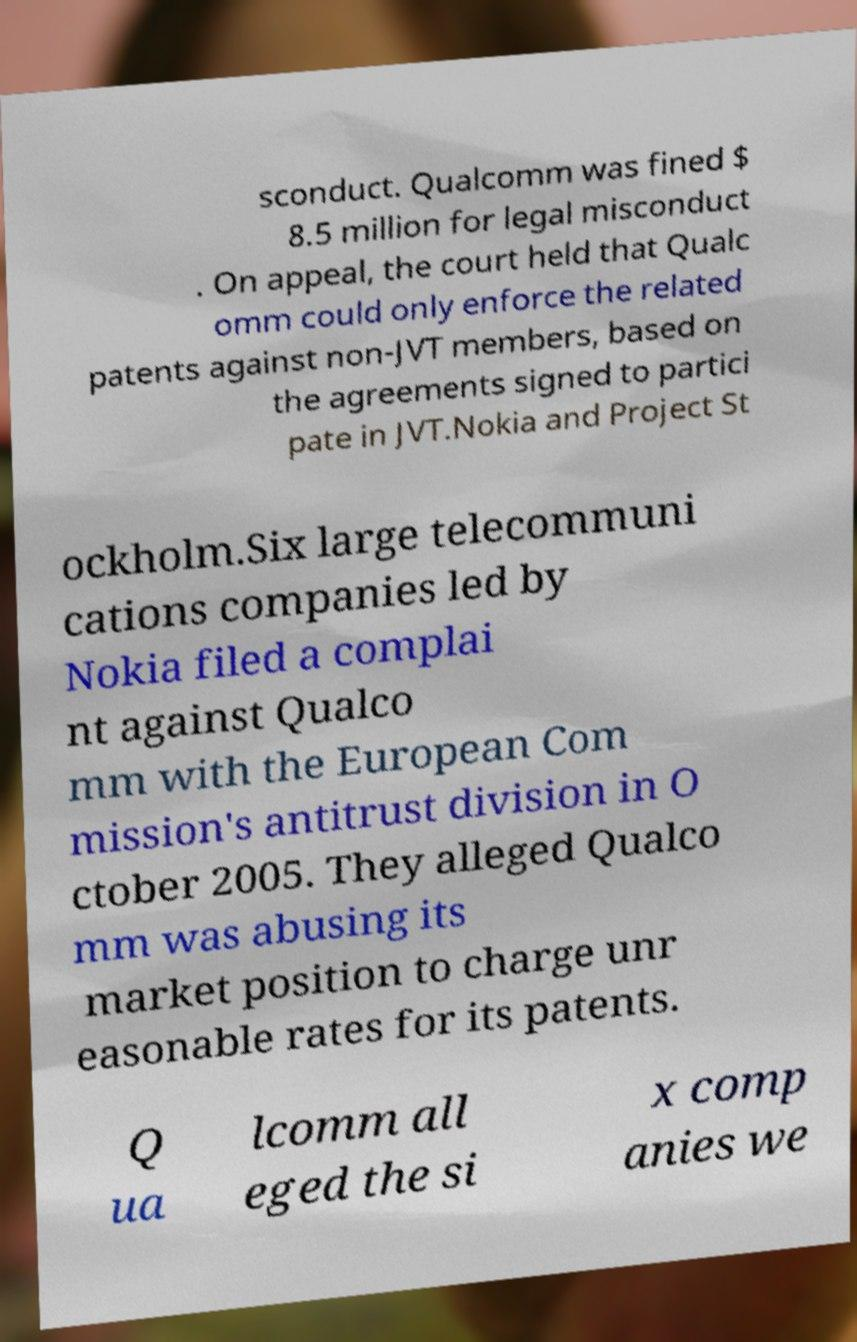I need the written content from this picture converted into text. Can you do that? sconduct. Qualcomm was fined $ 8.5 million for legal misconduct . On appeal, the court held that Qualc omm could only enforce the related patents against non-JVT members, based on the agreements signed to partici pate in JVT.Nokia and Project St ockholm.Six large telecommuni cations companies led by Nokia filed a complai nt against Qualco mm with the European Com mission's antitrust division in O ctober 2005. They alleged Qualco mm was abusing its market position to charge unr easonable rates for its patents. Q ua lcomm all eged the si x comp anies we 